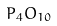Convert formula to latex. <formula><loc_0><loc_0><loc_500><loc_500>P _ { 4 } O _ { 1 0 }</formula> 